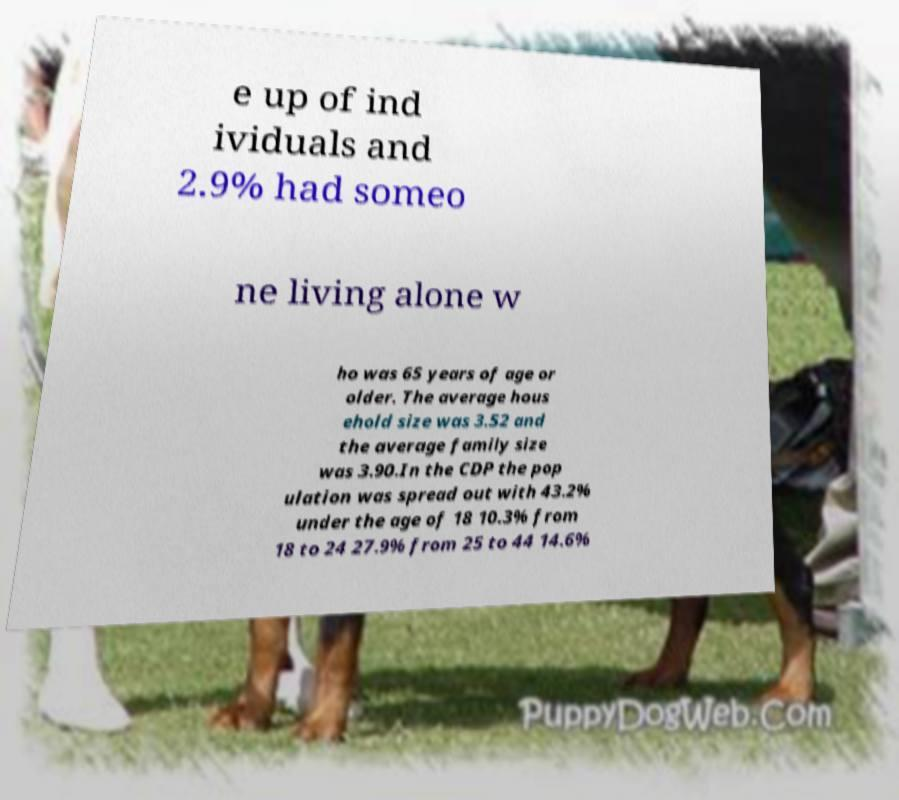What messages or text are displayed in this image? I need them in a readable, typed format. e up of ind ividuals and 2.9% had someo ne living alone w ho was 65 years of age or older. The average hous ehold size was 3.52 and the average family size was 3.90.In the CDP the pop ulation was spread out with 43.2% under the age of 18 10.3% from 18 to 24 27.9% from 25 to 44 14.6% 